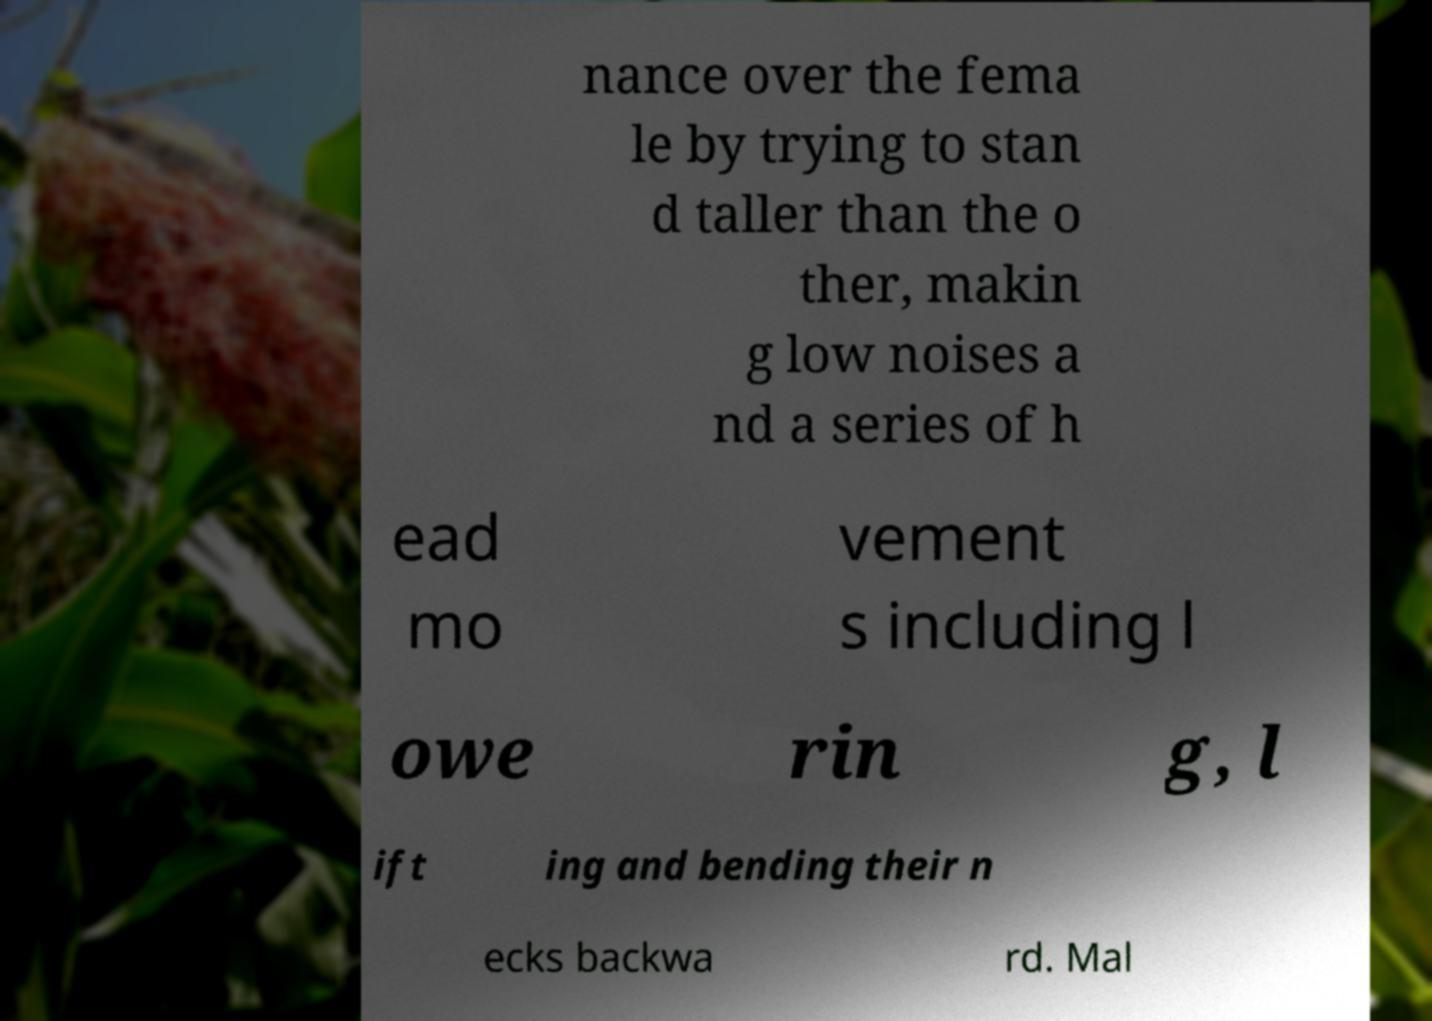Please read and relay the text visible in this image. What does it say? nance over the fema le by trying to stan d taller than the o ther, makin g low noises a nd a series of h ead mo vement s including l owe rin g, l ift ing and bending their n ecks backwa rd. Mal 